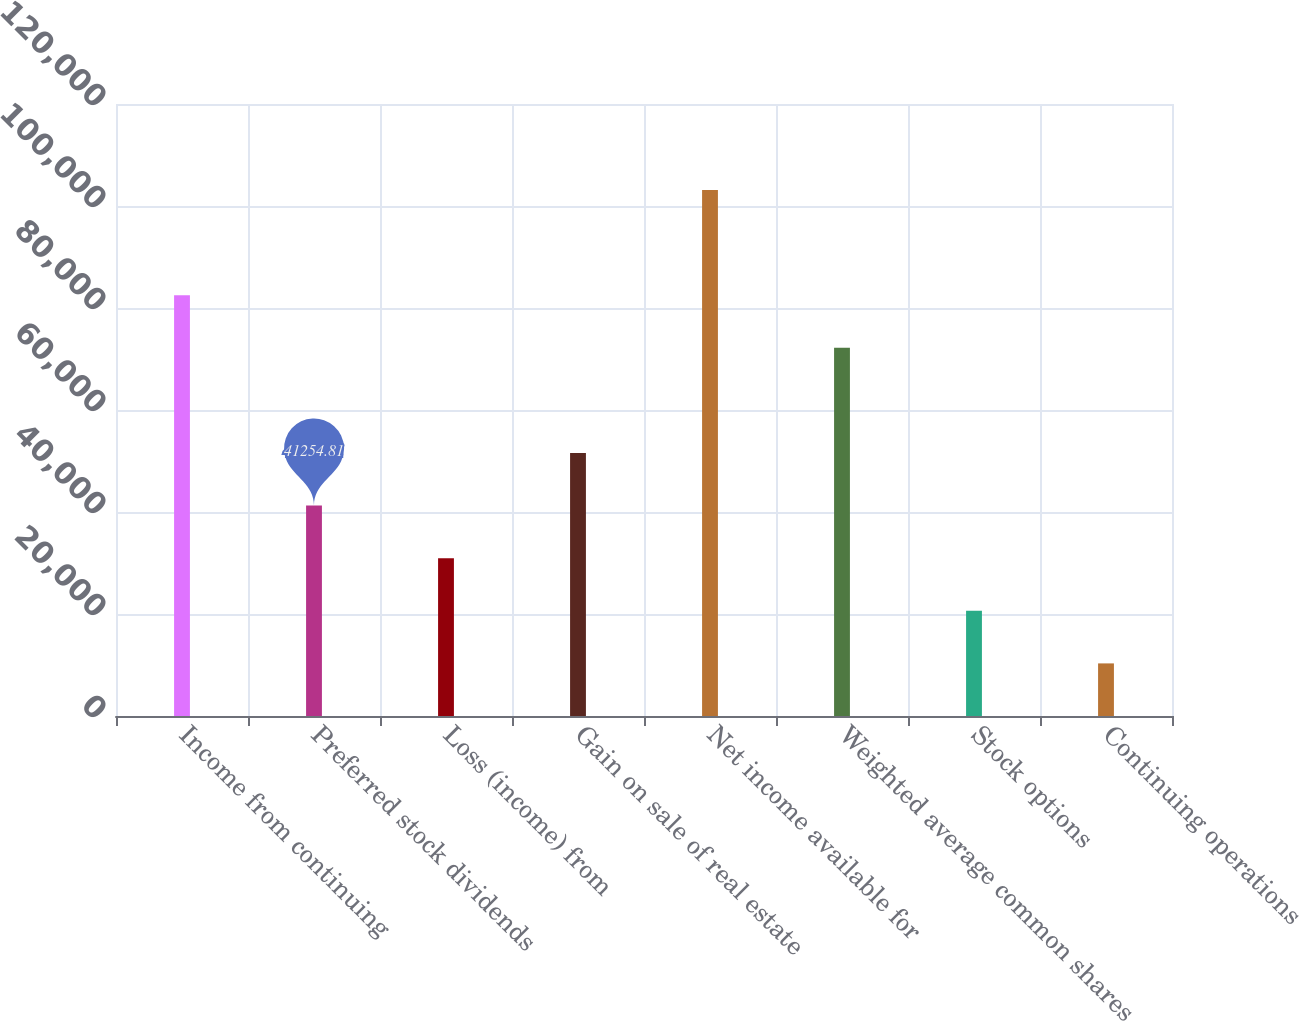<chart> <loc_0><loc_0><loc_500><loc_500><bar_chart><fcel>Income from continuing<fcel>Preferred stock dividends<fcel>Loss (income) from<fcel>Gain on sale of real estate<fcel>Net income available for<fcel>Weighted average common shares<fcel>Stock options<fcel>Continuing operations<nl><fcel>82509.6<fcel>41254.8<fcel>30941.1<fcel>51568.5<fcel>103137<fcel>72195.9<fcel>20627.4<fcel>10313.7<nl></chart> 